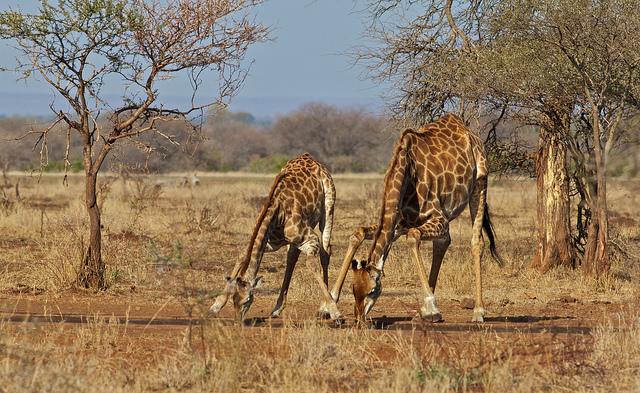Are the giraffes free?
Short answer required. Yes. What are the giraffes doing?
Give a very brief answer. Eating. Is this in the wild?
Keep it brief. Yes. 